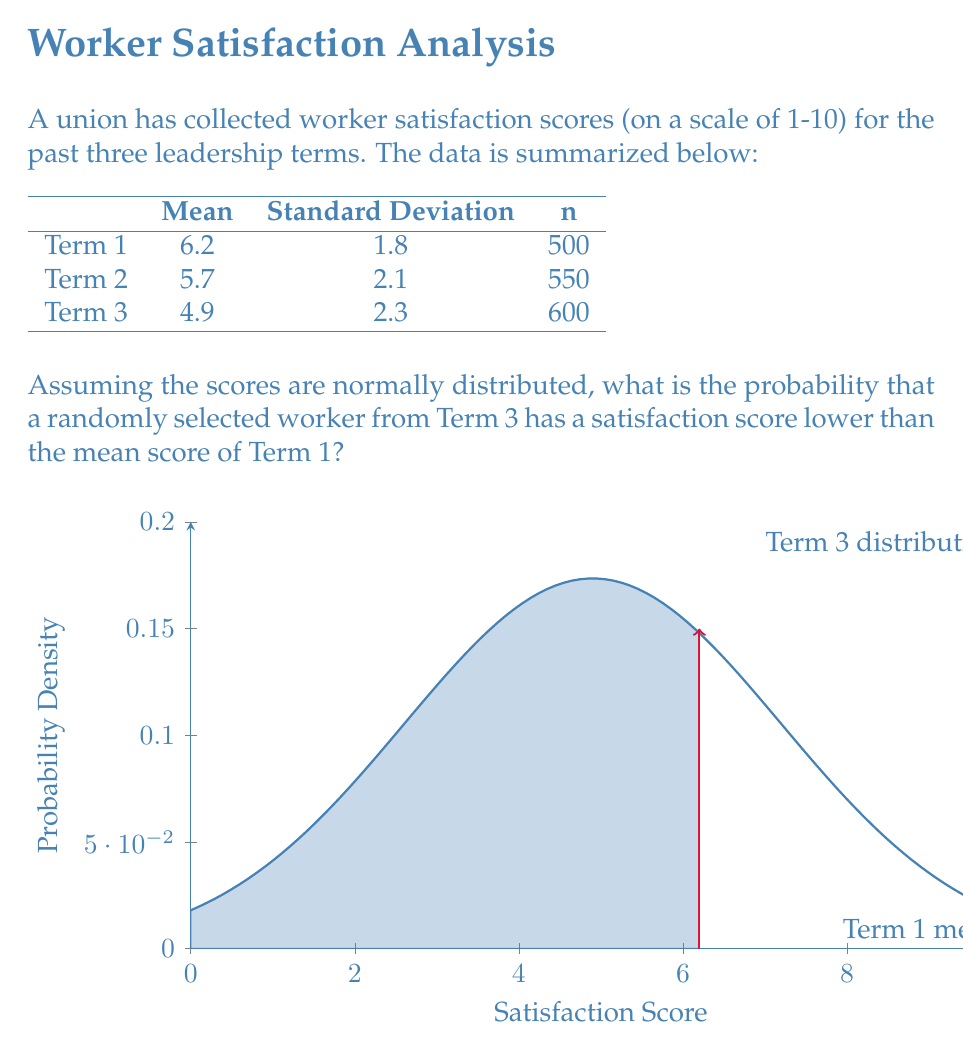Could you help me with this problem? Let's approach this step-by-step:

1) We're focusing on Term 3, where:
   Mean ($\mu$) = 4.9
   Standard Deviation ($\sigma$) = 2.3

2) We want to find the probability that a score is less than 6.2 (the mean of Term 1).

3) To do this, we need to calculate the z-score for 6.2 in the Term 3 distribution:

   $$z = \frac{x - \mu}{\sigma} = \frac{6.2 - 4.9}{2.3} = \frac{1.3}{2.3} \approx 0.5652$$

4) Now, we need to find the probability that a standard normal variable is less than 0.5652.

5) Using a standard normal table or calculator, we find:

   $$P(Z < 0.5652) \approx 0.7140$$

6) This means there's approximately a 71.40% chance that a randomly selected worker from Term 3 has a satisfaction score lower than the mean score of Term 1.

This high probability suggests a significant decline in worker satisfaction under the current leadership, which aligns with the perspective of a disgruntled union worker.
Answer: 0.7140 or 71.40% 